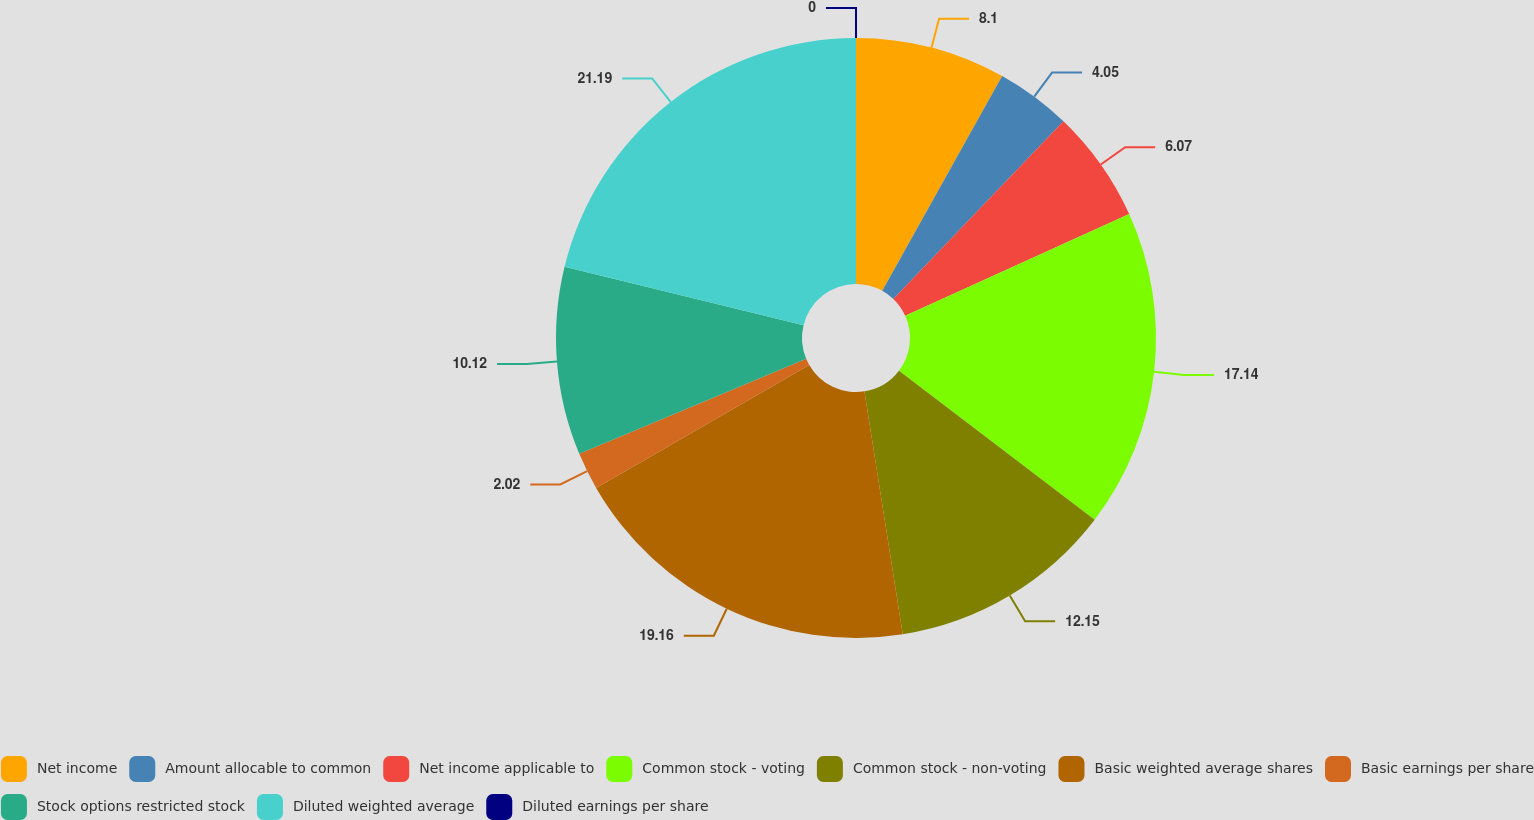Convert chart. <chart><loc_0><loc_0><loc_500><loc_500><pie_chart><fcel>Net income<fcel>Amount allocable to common<fcel>Net income applicable to<fcel>Common stock - voting<fcel>Common stock - non-voting<fcel>Basic weighted average shares<fcel>Basic earnings per share<fcel>Stock options restricted stock<fcel>Diluted weighted average<fcel>Diluted earnings per share<nl><fcel>8.1%<fcel>4.05%<fcel>6.07%<fcel>17.14%<fcel>12.15%<fcel>19.16%<fcel>2.02%<fcel>10.12%<fcel>21.19%<fcel>0.0%<nl></chart> 